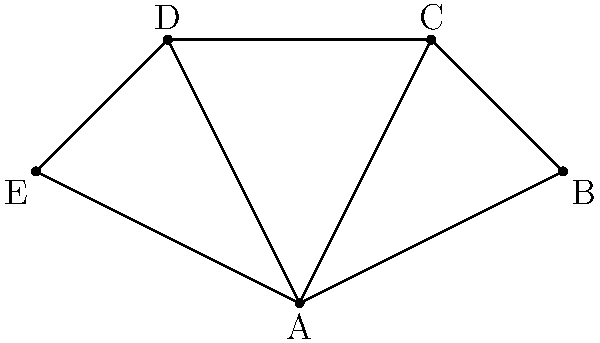In the network diagram representing refugee camps and their connections, which camp has the highest degree centrality, and what implications does this have for resource distribution and information flow? To answer this question, we need to follow these steps:

1. Understand degree centrality:
   Degree centrality is the number of direct connections a node has in a network.

2. Count connections for each node:
   A: 4 connections (to B, C, D, E)
   B: 2 connections (to A, C)
   C: 3 connections (to A, B, D)
   D: 3 connections (to A, C, E)
   E: 2 connections (to A, D)

3. Identify the highest degree centrality:
   Camp A has the highest degree centrality with 4 connections.

4. Analyze implications:
   a) Resource distribution: Camp A is in the best position to receive and distribute resources efficiently to other camps.
   b) Information flow: Camp A can quickly disseminate information to all other camps, acting as a central hub.
   c) Vulnerability: If Camp A is compromised, it could significantly disrupt the entire network.
   d) Coordination: Camp A is ideal for coordinating activities across the network of refugee camps.

5. Consider the perspective of an ex-war correspondent:
   The high centrality of Camp A reflects real-world scenarios where certain refugee camps become focal points for aid distribution and information sharing, often due to their strategic location or established infrastructure.
Answer: Camp A; central hub for resource distribution and information flow 